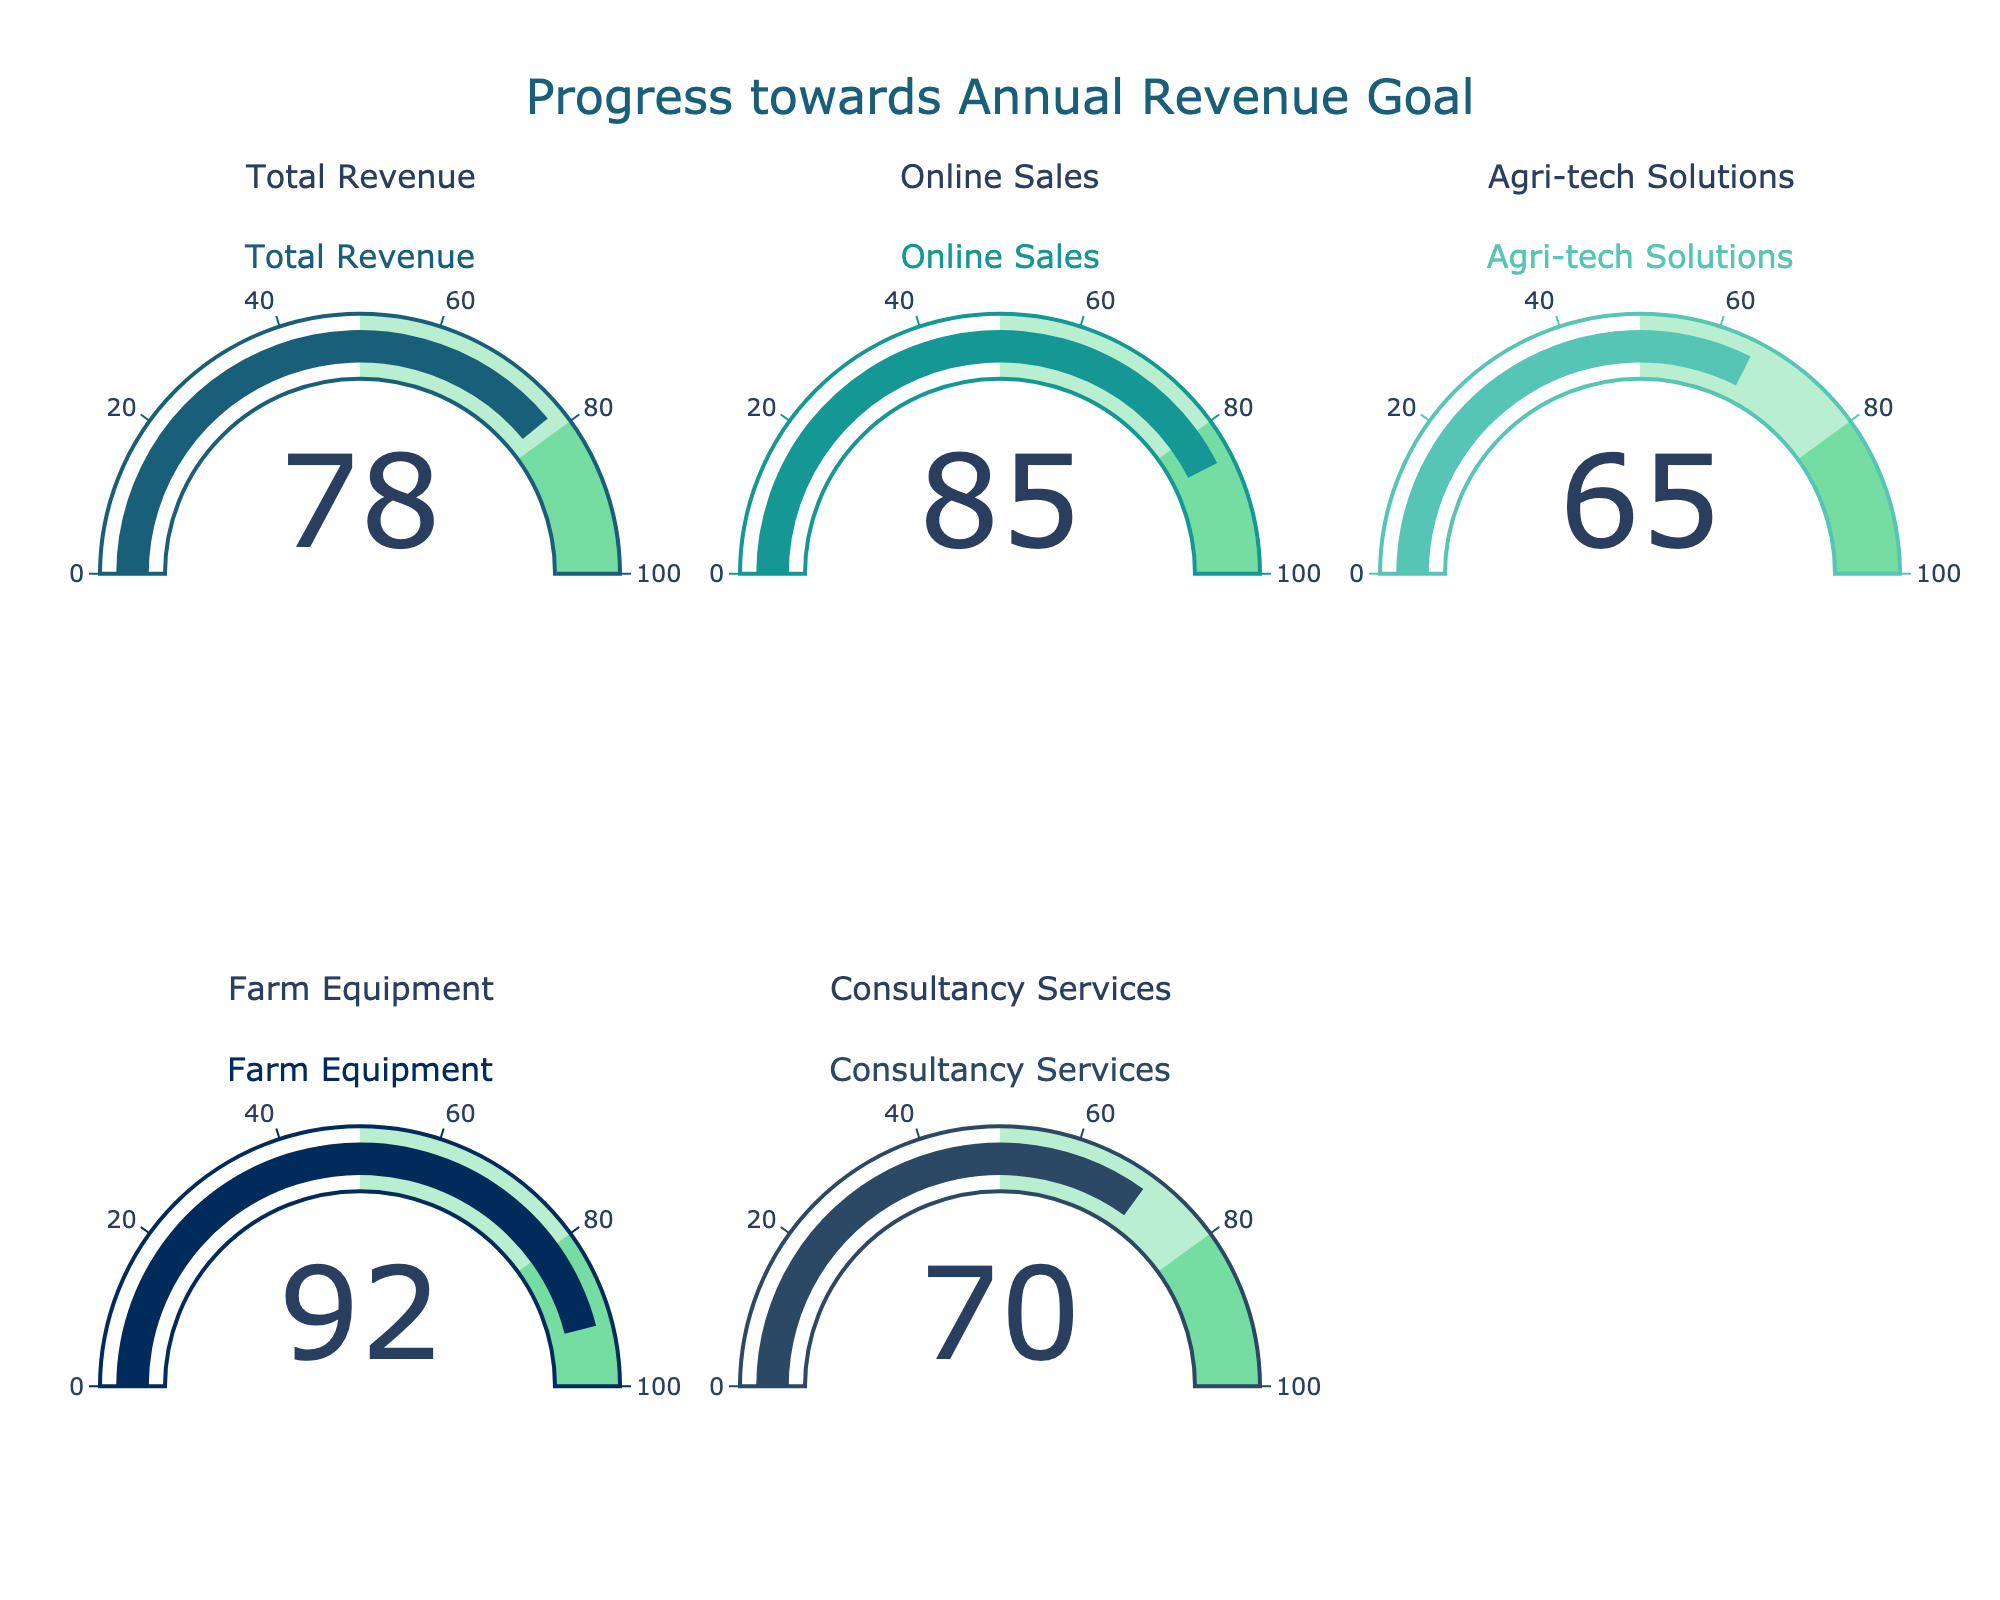what is the title of the figure? The title of the figure is located at the top center of the chart and is clearly written. It says "Progress towards Annual Revenue Goal".
Answer: Progress towards Annual Revenue Goal what category has the highest progress value? By observing the gauge readings, the category with the highest progress value is the one where the needle is closest to 100. In this case, it is "Farm Equipment" with a progress of 92.
Answer: Farm Equipment how many categories have a progress value greater than 80? There are five gauge charts, and we can check each one's value to determine how many have progress values greater than 80. "Online Sales" (85) and "Farm Equipment" (92) are both greater than 80, which makes it a total of two categories.
Answer: 2 what is the total progress value of "Total Revenue" and "Consultancy Services"? The progress values for "Total Revenue" and "Consultancy Services" are 78 and 70, respectively. Summing these values results in 78 + 70 = 148.
Answer: 148 compare "Agri-tech Solutions" and "Consultancy Services"; which has a lower progress? The progress value for "Agri-tech Solutions" is 65, and the progress value for "Consultancy Services" is 70. Since 65 is less than 70, "Agri-tech Solutions" has a lower progress.
Answer: Agri-tech Solutions how much more progress is needed for "Online Sales" to reach 100? "Online Sales" currently has a progress value of 85. To reach 100, it needs an additional 100 - 85 = 15 units.
Answer: 15 what is the average progress of all categories? First, add all the progress values together: 78 (Total Revenue) + 85 (Online Sales) + 65 (Agri-tech Solutions) + 92 (Farm Equipment) + 70 (Consultancy Services) = 390. Then divide by the number of categories (5): 390 / 5 = 78.
Answer: 78 which progress value is exactly halfway between the lowest and the highest progress values? The lowest progress value is 65 (Agri-tech Solutions) and the highest is 92 (Farm Equipment). The halfway point between 65 and 92 is calculated as (65 + 92) / 2 = 78.5. Since there is no exact match, there is no progress value that is exactly halfway.
Answer: None 